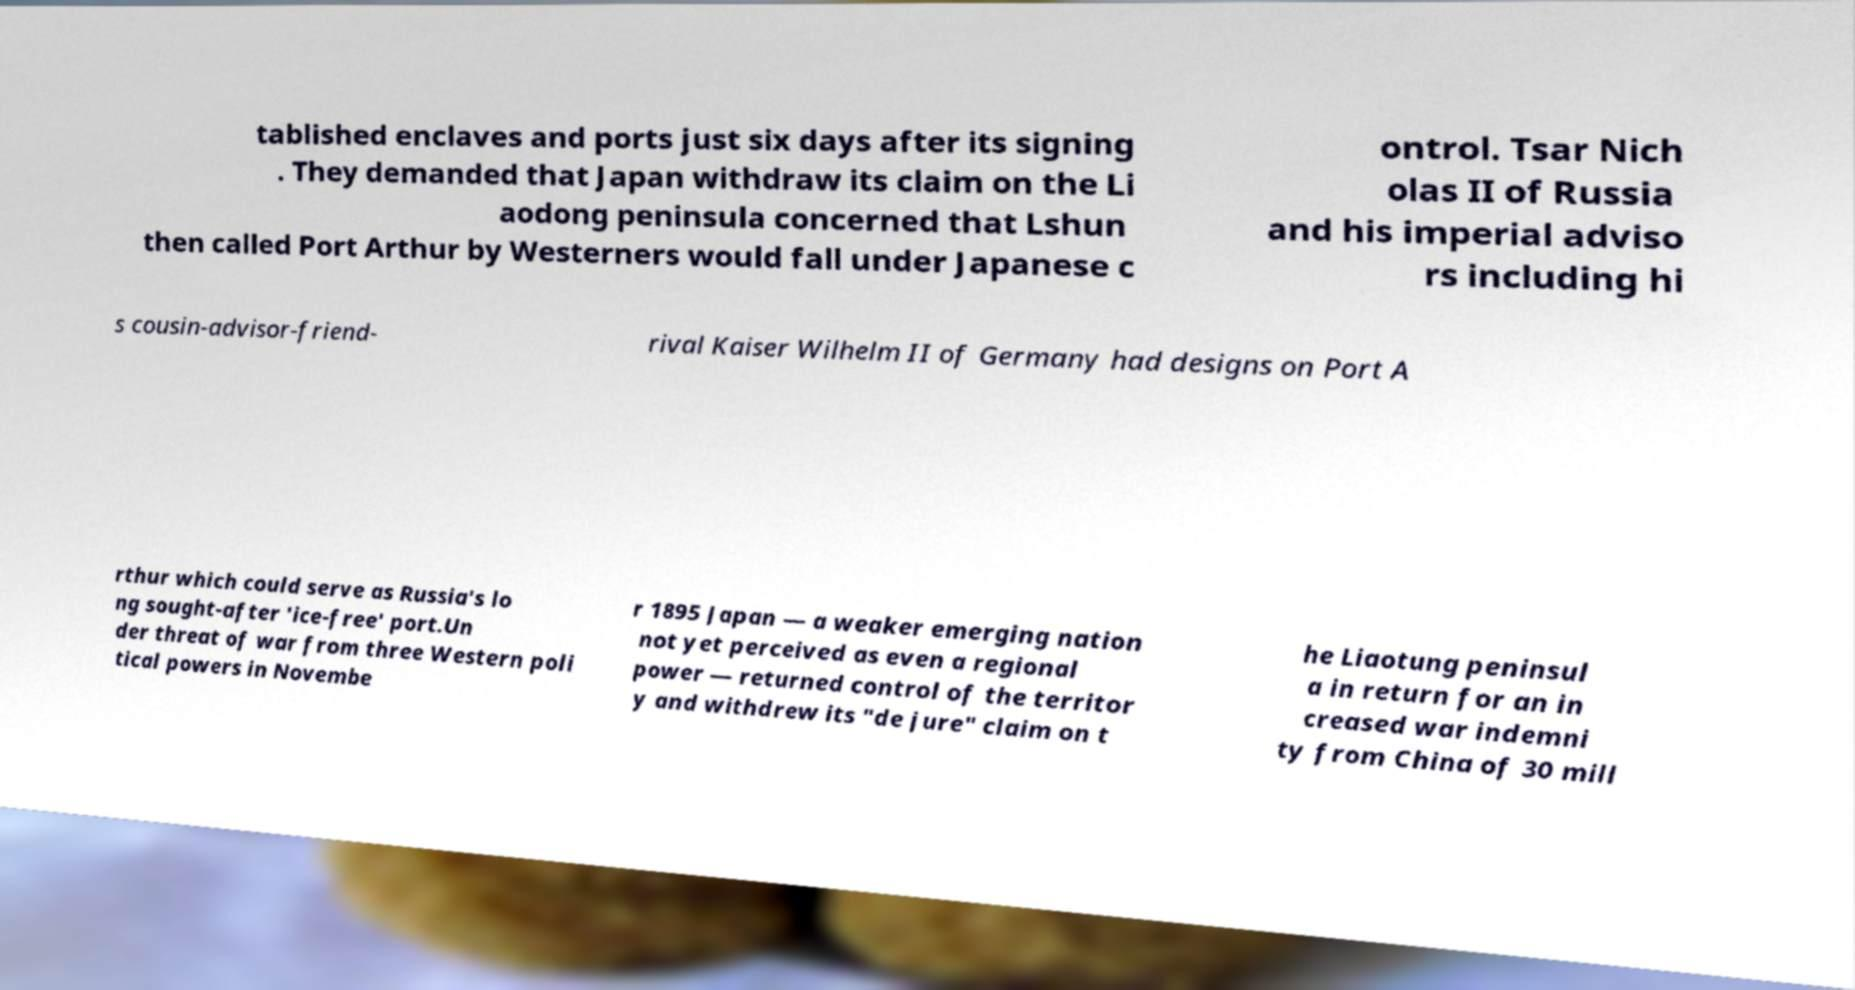Can you read and provide the text displayed in the image?This photo seems to have some interesting text. Can you extract and type it out for me? tablished enclaves and ports just six days after its signing . They demanded that Japan withdraw its claim on the Li aodong peninsula concerned that Lshun then called Port Arthur by Westerners would fall under Japanese c ontrol. Tsar Nich olas II of Russia and his imperial adviso rs including hi s cousin-advisor-friend- rival Kaiser Wilhelm II of Germany had designs on Port A rthur which could serve as Russia's lo ng sought-after 'ice-free' port.Un der threat of war from three Western poli tical powers in Novembe r 1895 Japan — a weaker emerging nation not yet perceived as even a regional power — returned control of the territor y and withdrew its "de jure" claim on t he Liaotung peninsul a in return for an in creased war indemni ty from China of 30 mill 